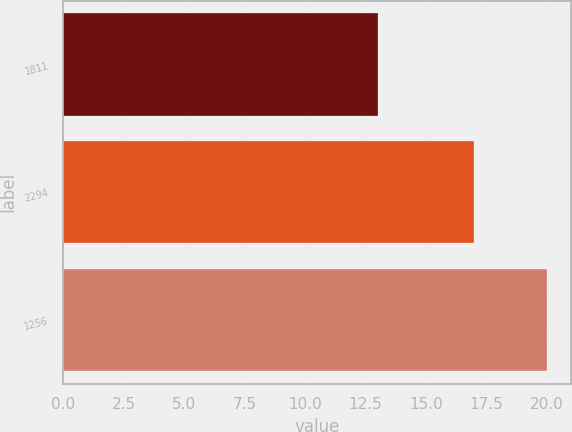<chart> <loc_0><loc_0><loc_500><loc_500><bar_chart><fcel>1811<fcel>2294<fcel>1256<nl><fcel>13<fcel>17<fcel>20<nl></chart> 